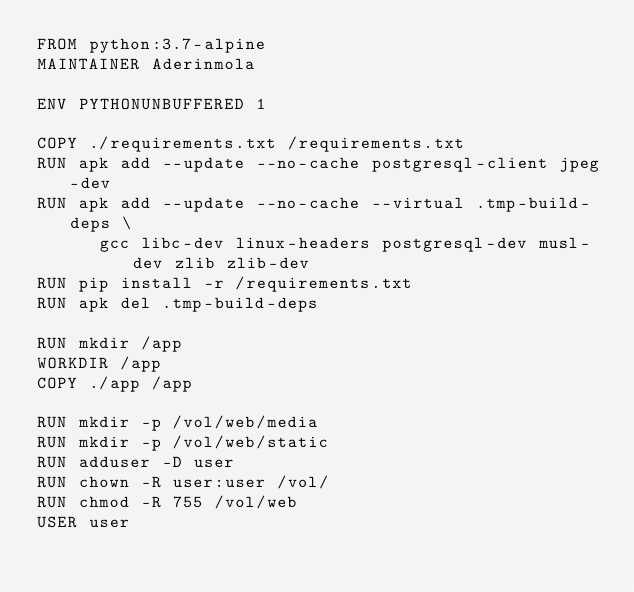Convert code to text. <code><loc_0><loc_0><loc_500><loc_500><_Dockerfile_>FROM python:3.7-alpine
MAINTAINER Aderinmola

ENV PYTHONUNBUFFERED 1

COPY ./requirements.txt /requirements.txt
RUN apk add --update --no-cache postgresql-client jpeg-dev
RUN apk add --update --no-cache --virtual .tmp-build-deps \
      gcc libc-dev linux-headers postgresql-dev musl-dev zlib zlib-dev
RUN pip install -r /requirements.txt
RUN apk del .tmp-build-deps

RUN mkdir /app
WORKDIR /app
COPY ./app /app

RUN mkdir -p /vol/web/media
RUN mkdir -p /vol/web/static
RUN adduser -D user
RUN chown -R user:user /vol/
RUN chmod -R 755 /vol/web
USER user
</code> 